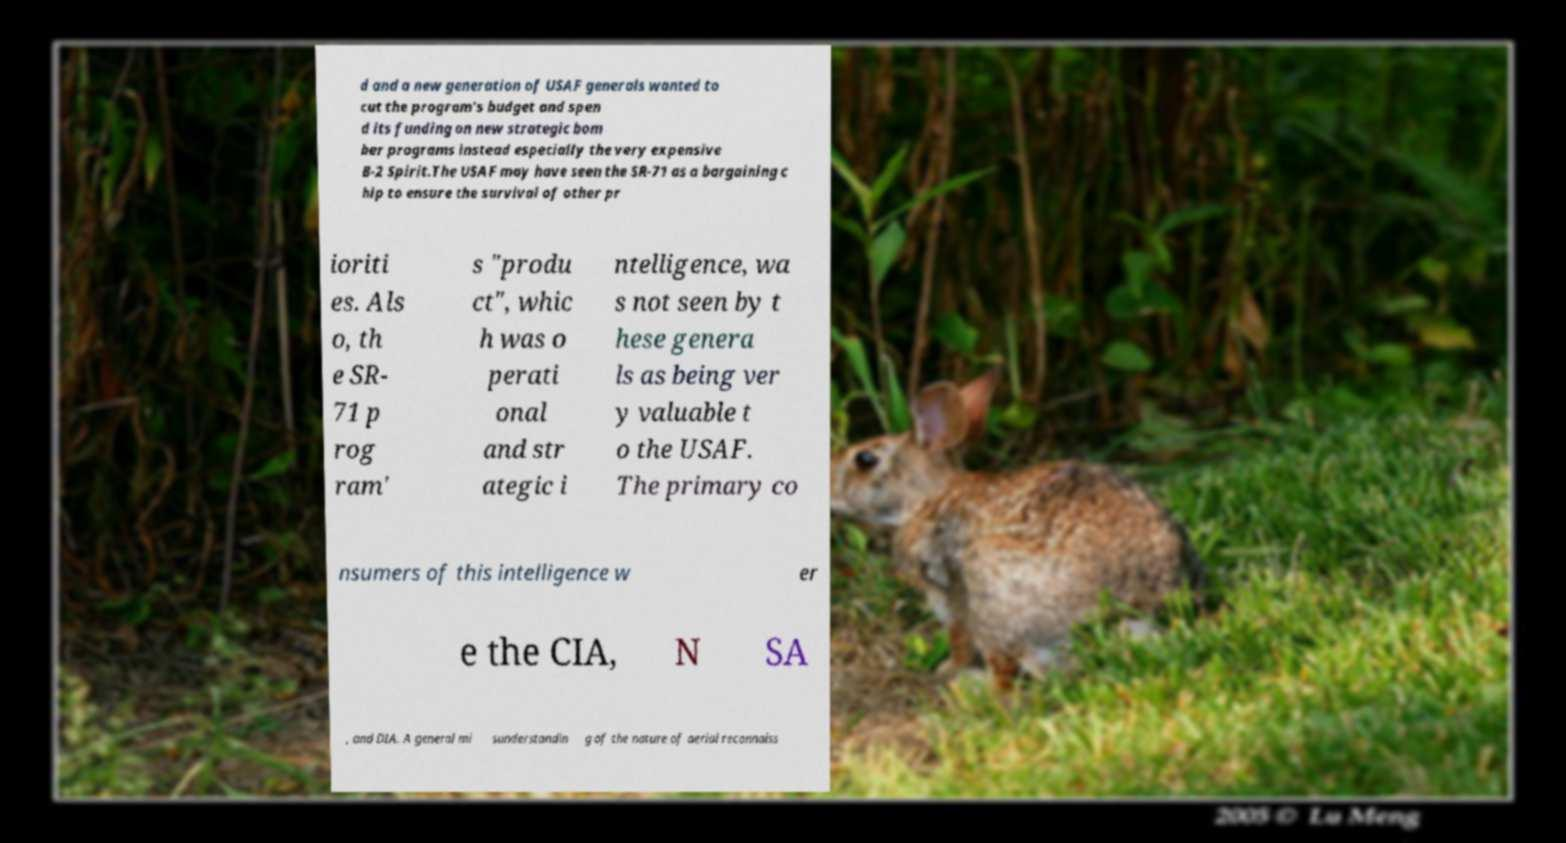Can you read and provide the text displayed in the image?This photo seems to have some interesting text. Can you extract and type it out for me? d and a new generation of USAF generals wanted to cut the program's budget and spen d its funding on new strategic bom ber programs instead especially the very expensive B-2 Spirit.The USAF may have seen the SR-71 as a bargaining c hip to ensure the survival of other pr ioriti es. Als o, th e SR- 71 p rog ram' s "produ ct", whic h was o perati onal and str ategic i ntelligence, wa s not seen by t hese genera ls as being ver y valuable t o the USAF. The primary co nsumers of this intelligence w er e the CIA, N SA , and DIA. A general mi sunderstandin g of the nature of aerial reconnaiss 